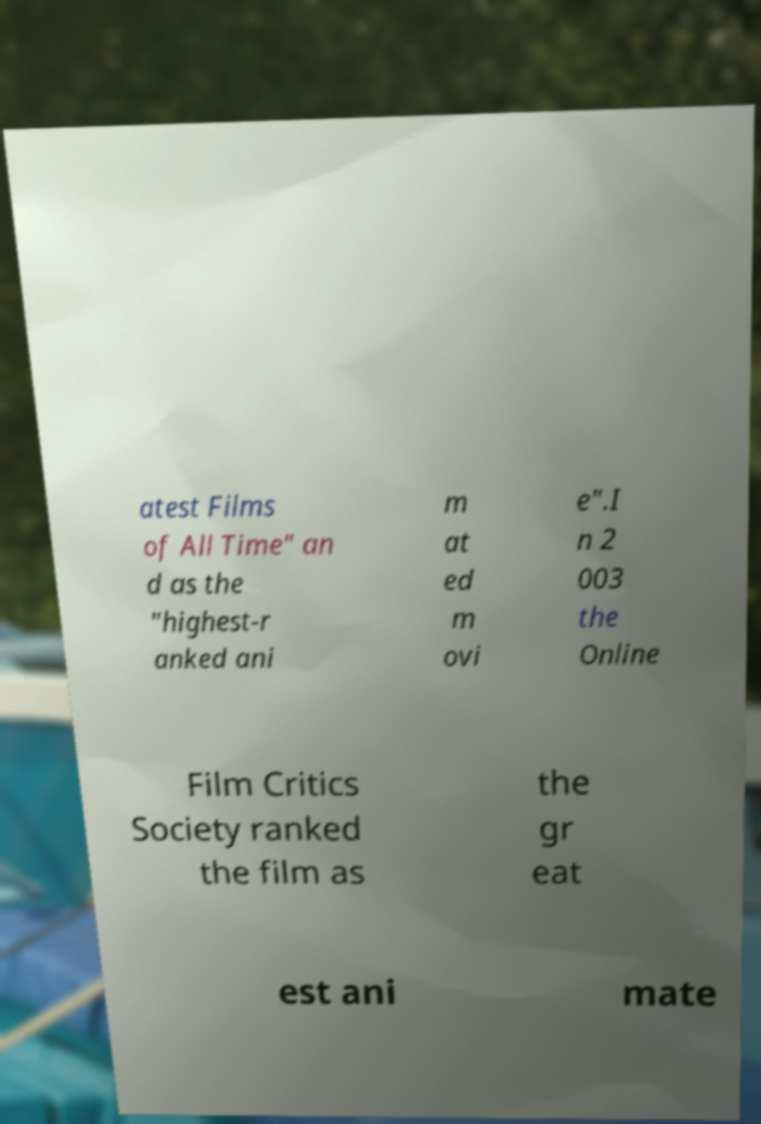Can you read and provide the text displayed in the image?This photo seems to have some interesting text. Can you extract and type it out for me? atest Films of All Time" an d as the "highest-r anked ani m at ed m ovi e".I n 2 003 the Online Film Critics Society ranked the film as the gr eat est ani mate 